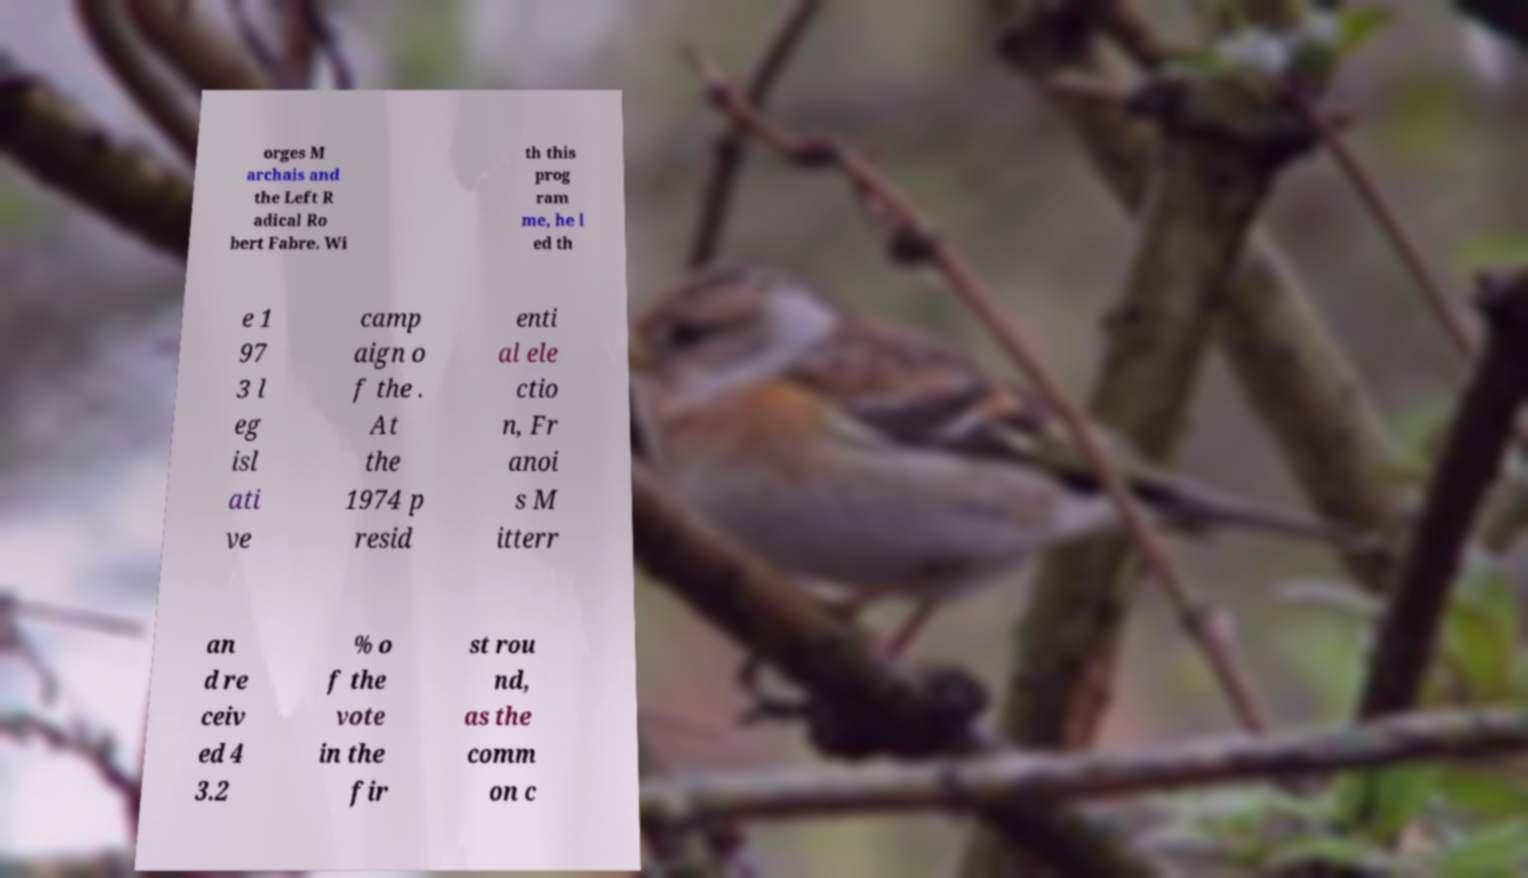Can you accurately transcribe the text from the provided image for me? orges M archais and the Left R adical Ro bert Fabre. Wi th this prog ram me, he l ed th e 1 97 3 l eg isl ati ve camp aign o f the . At the 1974 p resid enti al ele ctio n, Fr anoi s M itterr an d re ceiv ed 4 3.2 % o f the vote in the fir st rou nd, as the comm on c 